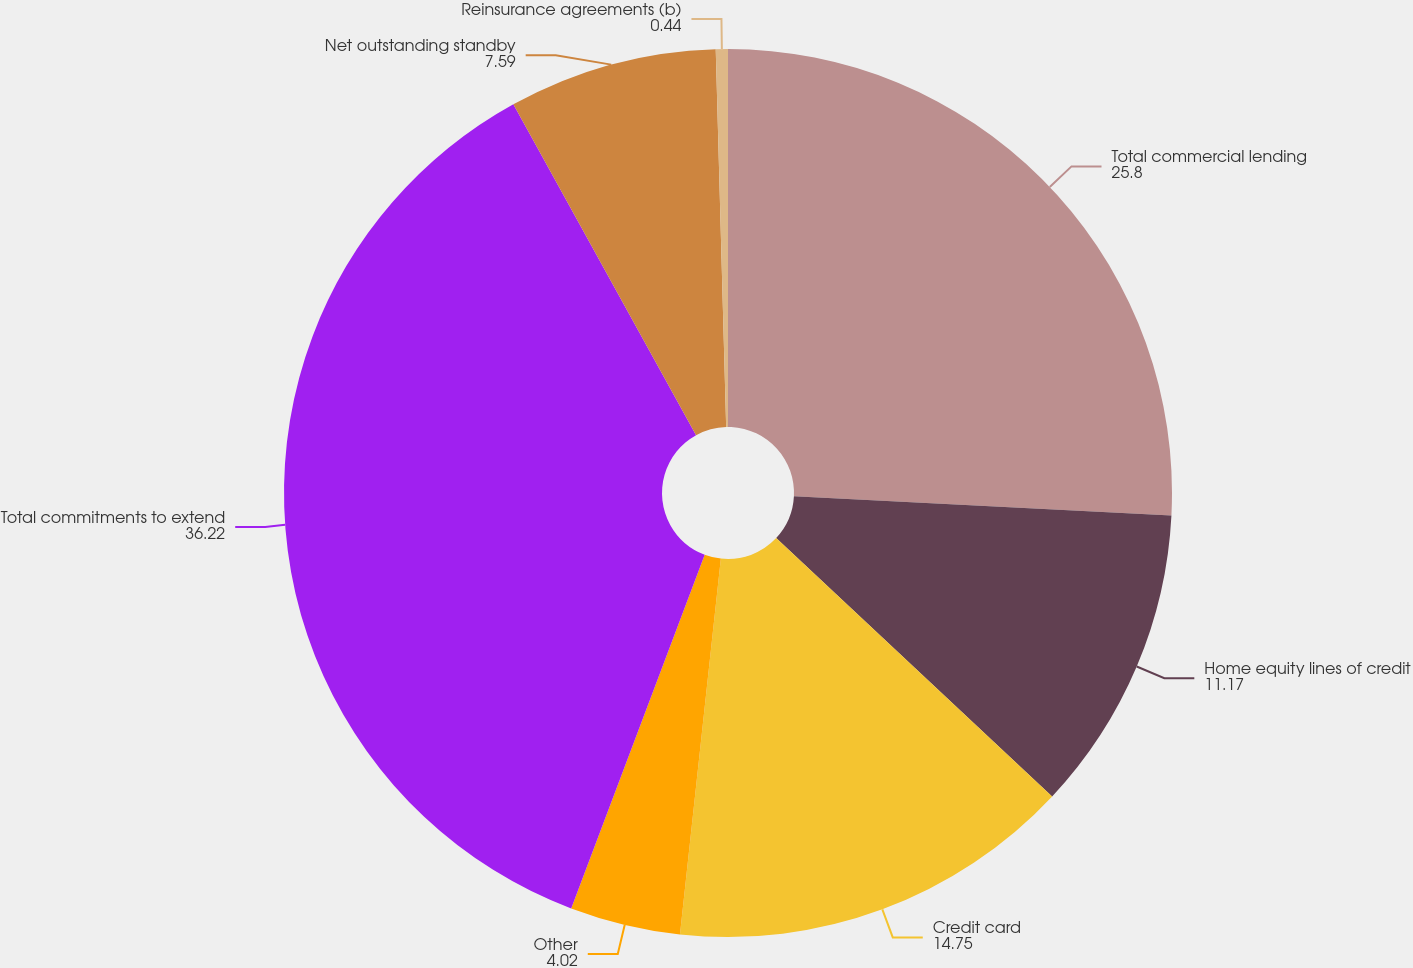<chart> <loc_0><loc_0><loc_500><loc_500><pie_chart><fcel>Total commercial lending<fcel>Home equity lines of credit<fcel>Credit card<fcel>Other<fcel>Total commitments to extend<fcel>Net outstanding standby<fcel>Reinsurance agreements (b)<nl><fcel>25.8%<fcel>11.17%<fcel>14.75%<fcel>4.02%<fcel>36.22%<fcel>7.59%<fcel>0.44%<nl></chart> 